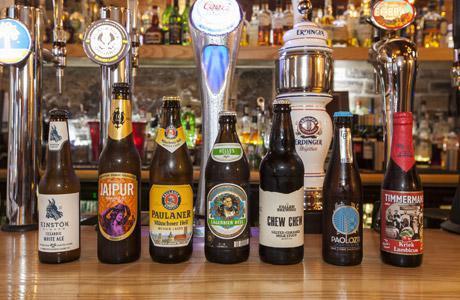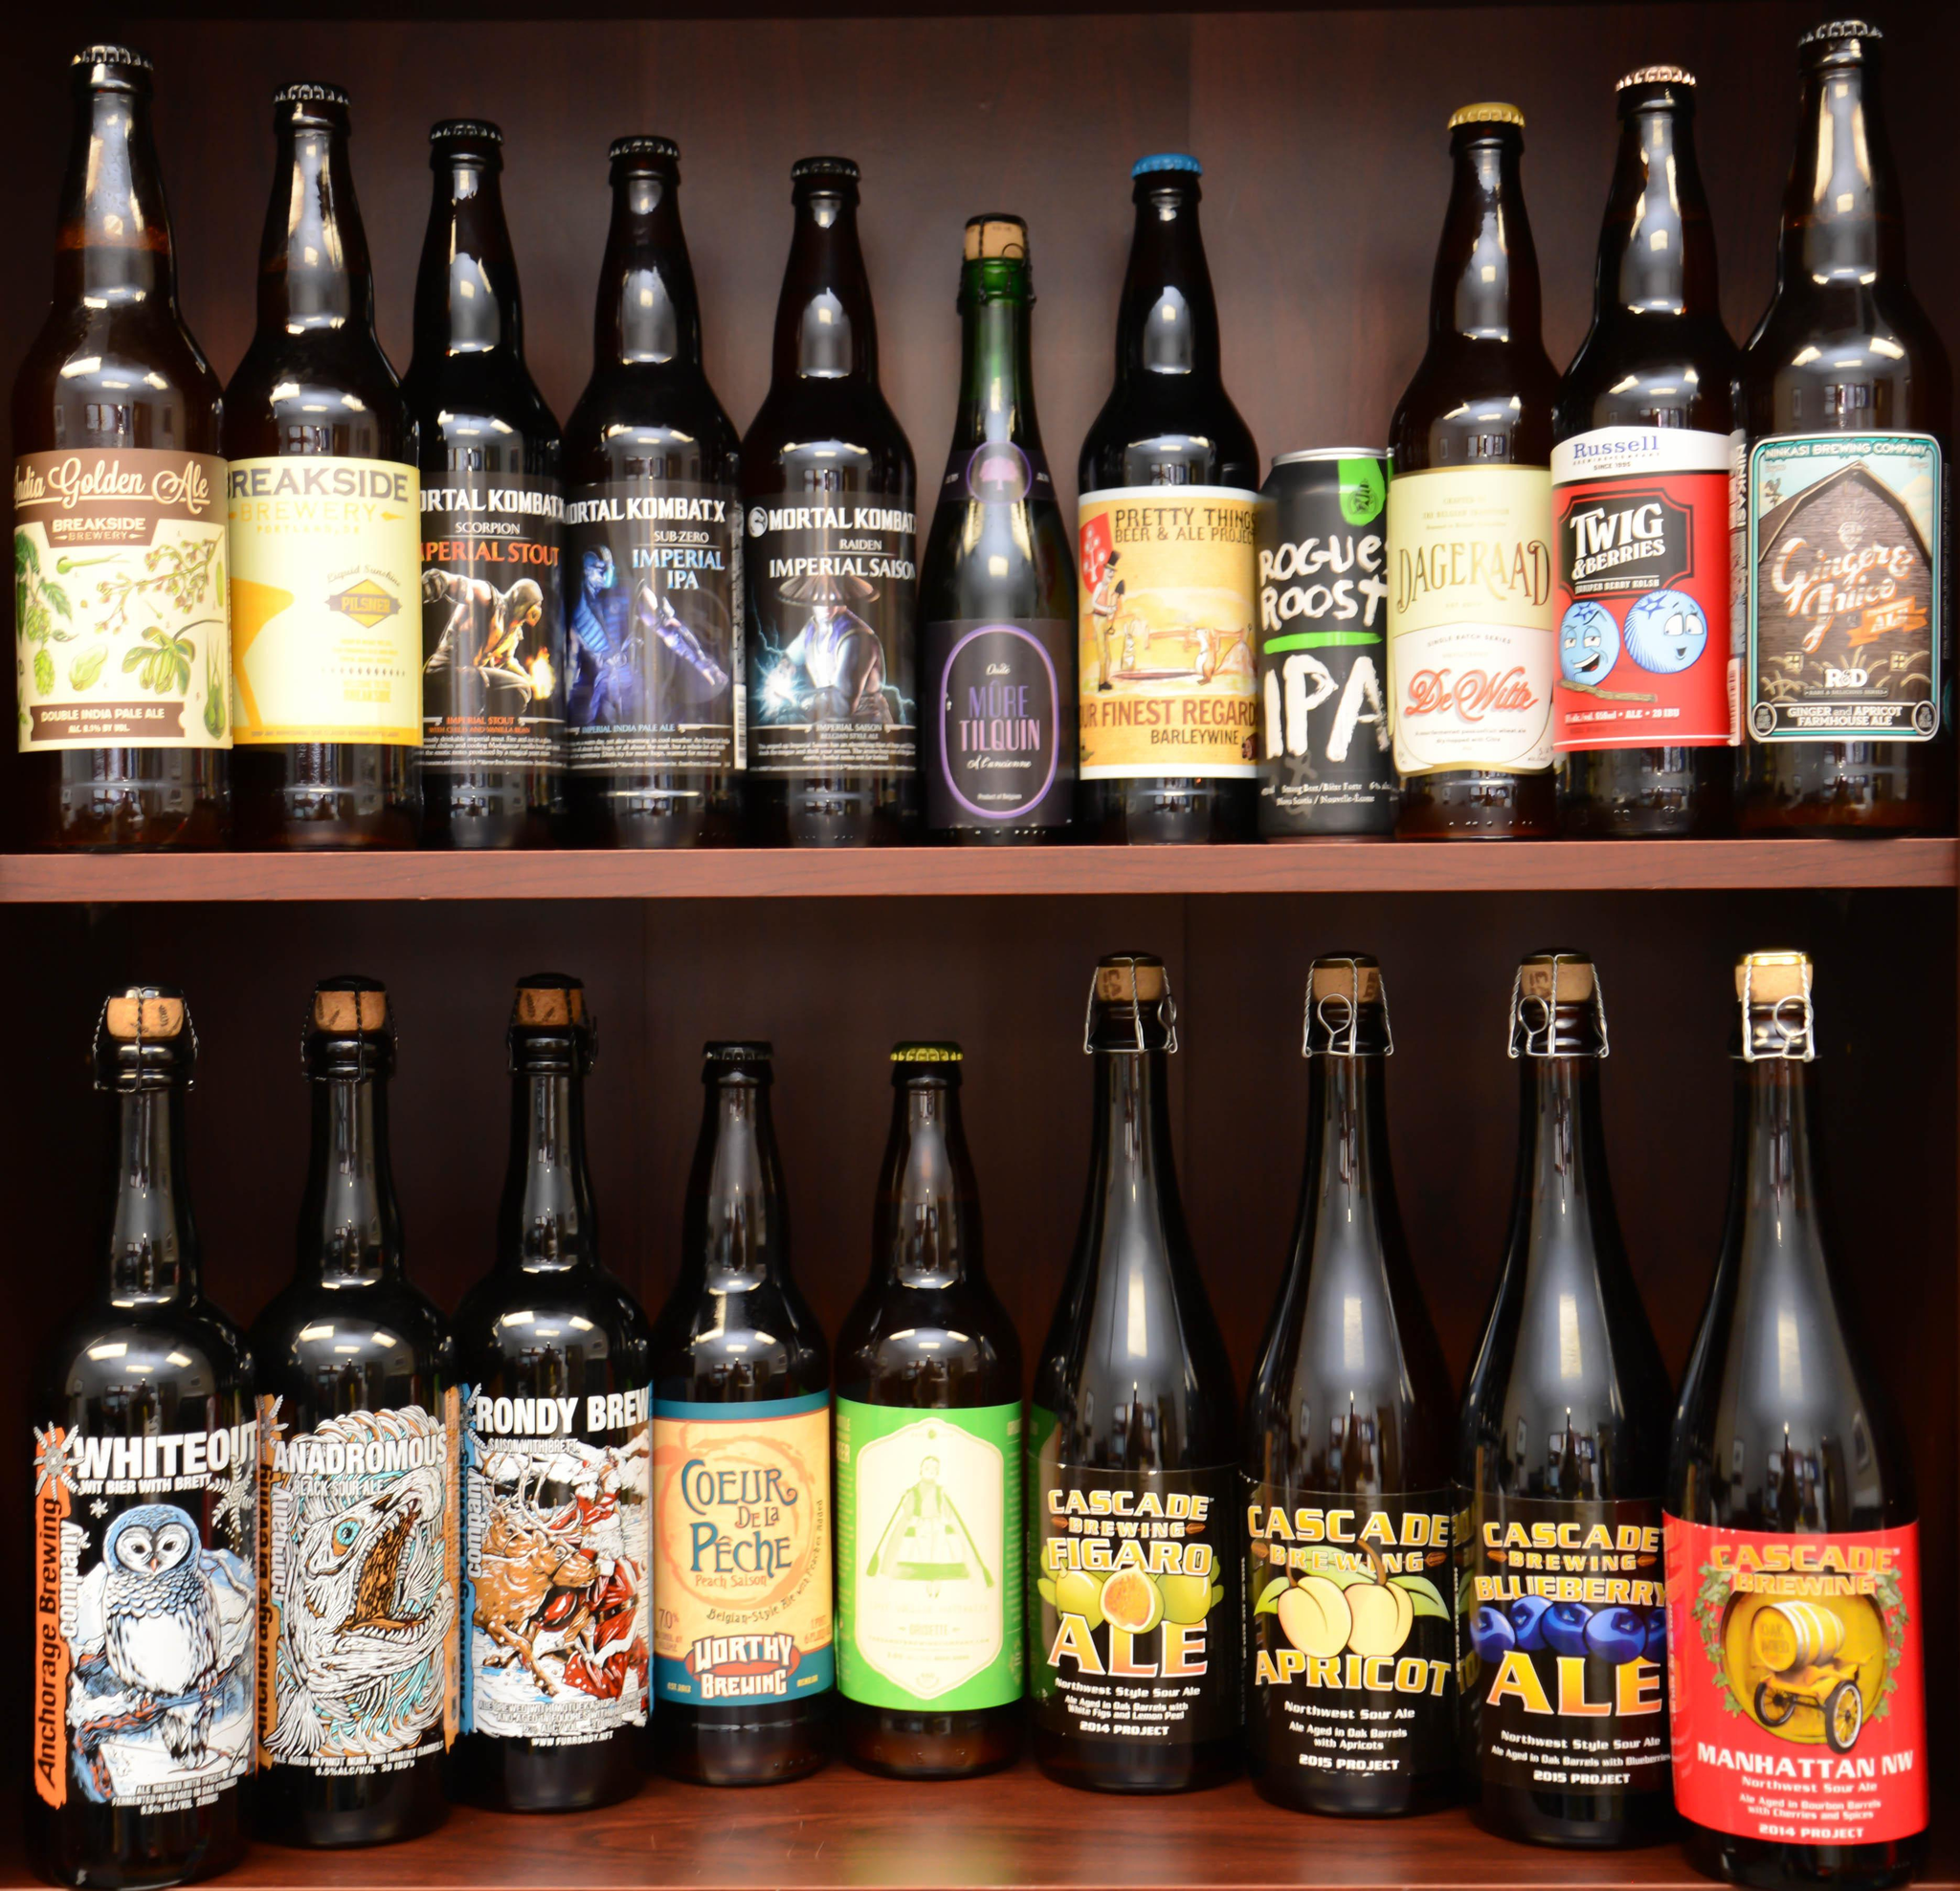The first image is the image on the left, the second image is the image on the right. Considering the images on both sides, is "There are two levels of beer bottles." valid? Answer yes or no. Yes. 